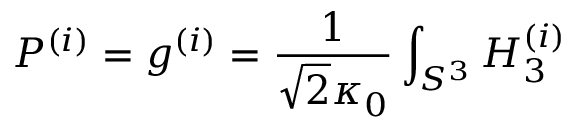Convert formula to latex. <formula><loc_0><loc_0><loc_500><loc_500>P ^ { ( i ) } = g ^ { ( i ) } = \frac { 1 } { \sqrt { 2 } \kappa _ { 0 } } \int _ { S ^ { 3 } } H _ { 3 } ^ { ( i ) }</formula> 